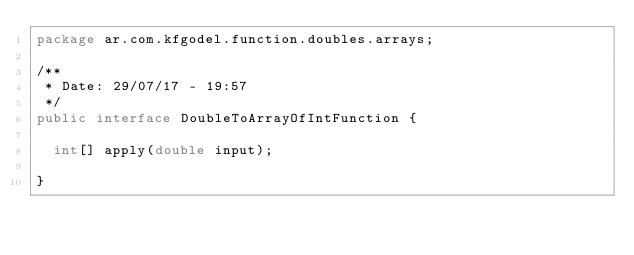Convert code to text. <code><loc_0><loc_0><loc_500><loc_500><_Java_>package ar.com.kfgodel.function.doubles.arrays;

/**
 * Date: 29/07/17 - 19:57
 */
public interface DoubleToArrayOfIntFunction {

  int[] apply(double input);

}
</code> 